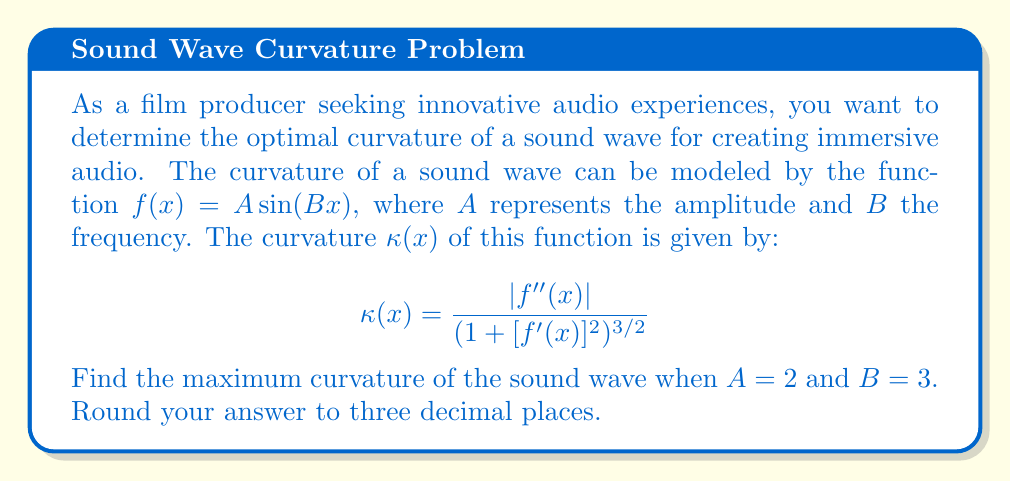Give your solution to this math problem. To solve this problem, we'll follow these steps:

1) First, let's find $f'(x)$ and $f''(x)$:
   $f(x) = 2 \sin(3x)$
   $f'(x) = 6 \cos(3x)$
   $f''(x) = -18 \sin(3x)$

2) Now, let's substitute these into the curvature formula:

   $$\kappa(x) = \frac{|-18 \sin(3x)|}{(1 + [6 \cos(3x)]^2)^{3/2}}$$

3) To find the maximum curvature, we need to find where the derivative of $\kappa(x)$ equals zero. However, this is a complex calculation. Instead, we can observe that the maximum curvature will occur when $|\sin(3x)|$ is at its maximum (1) and $\cos(3x)$ is at its minimum (0).

4) This occurs when $3x = \frac{\pi}{2}$ or $\frac{3\pi}{2}$, etc.

5) At these points, the curvature becomes:

   $$\kappa_{max} = \frac{18}{(1 + 0^2)^{3/2}} = 18$$

6) Therefore, the maximum curvature is 18.
Answer: 18.000 